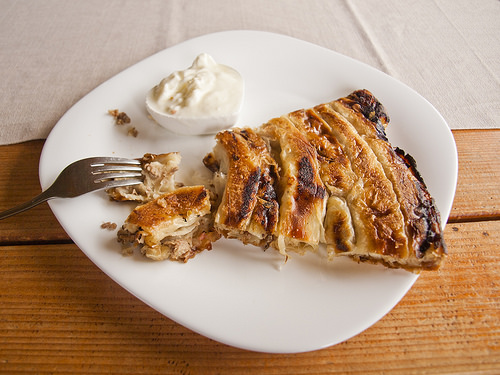<image>
Can you confirm if the fork is next to the plate? No. The fork is not positioned next to the plate. They are located in different areas of the scene. 